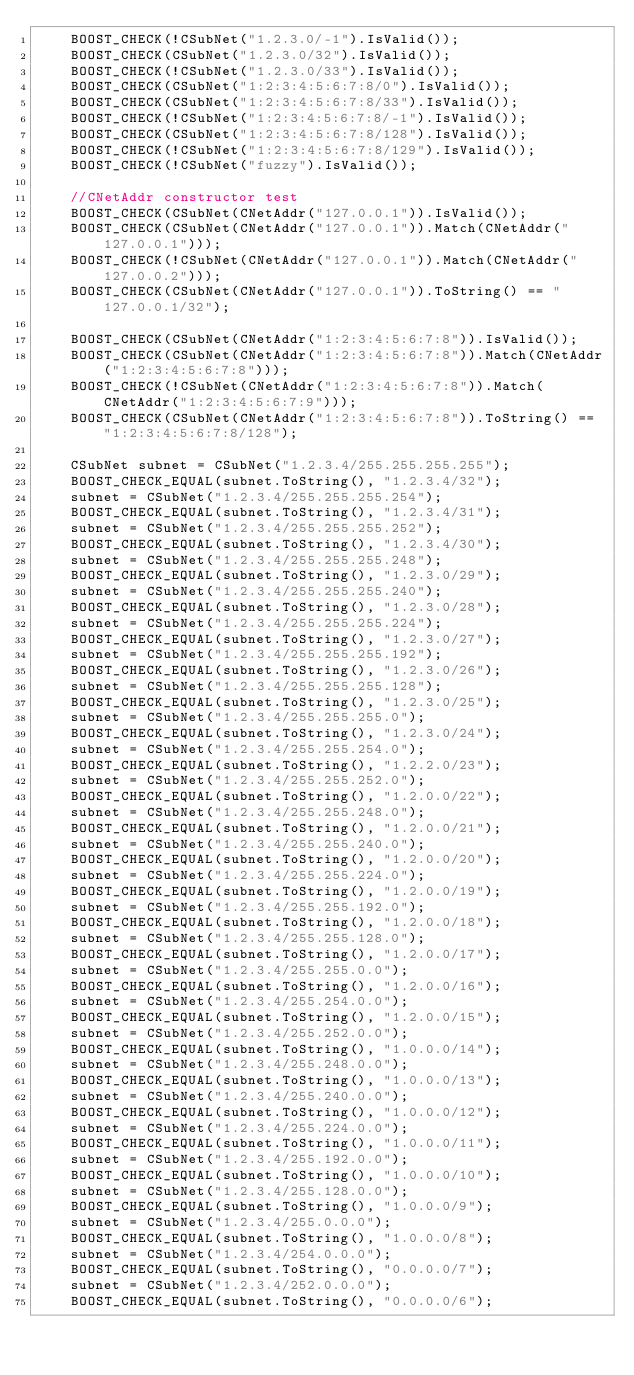Convert code to text. <code><loc_0><loc_0><loc_500><loc_500><_C++_>    BOOST_CHECK(!CSubNet("1.2.3.0/-1").IsValid());
    BOOST_CHECK(CSubNet("1.2.3.0/32").IsValid());
    BOOST_CHECK(!CSubNet("1.2.3.0/33").IsValid());
    BOOST_CHECK(CSubNet("1:2:3:4:5:6:7:8/0").IsValid());
    BOOST_CHECK(CSubNet("1:2:3:4:5:6:7:8/33").IsValid());
    BOOST_CHECK(!CSubNet("1:2:3:4:5:6:7:8/-1").IsValid());
    BOOST_CHECK(CSubNet("1:2:3:4:5:6:7:8/128").IsValid());
    BOOST_CHECK(!CSubNet("1:2:3:4:5:6:7:8/129").IsValid());
    BOOST_CHECK(!CSubNet("fuzzy").IsValid());

    //CNetAddr constructor test
    BOOST_CHECK(CSubNet(CNetAddr("127.0.0.1")).IsValid());
    BOOST_CHECK(CSubNet(CNetAddr("127.0.0.1")).Match(CNetAddr("127.0.0.1")));
    BOOST_CHECK(!CSubNet(CNetAddr("127.0.0.1")).Match(CNetAddr("127.0.0.2")));
    BOOST_CHECK(CSubNet(CNetAddr("127.0.0.1")).ToString() == "127.0.0.1/32");

    BOOST_CHECK(CSubNet(CNetAddr("1:2:3:4:5:6:7:8")).IsValid());
    BOOST_CHECK(CSubNet(CNetAddr("1:2:3:4:5:6:7:8")).Match(CNetAddr("1:2:3:4:5:6:7:8")));
    BOOST_CHECK(!CSubNet(CNetAddr("1:2:3:4:5:6:7:8")).Match(CNetAddr("1:2:3:4:5:6:7:9")));
    BOOST_CHECK(CSubNet(CNetAddr("1:2:3:4:5:6:7:8")).ToString() == "1:2:3:4:5:6:7:8/128");

    CSubNet subnet = CSubNet("1.2.3.4/255.255.255.255");
    BOOST_CHECK_EQUAL(subnet.ToString(), "1.2.3.4/32");
    subnet = CSubNet("1.2.3.4/255.255.255.254");
    BOOST_CHECK_EQUAL(subnet.ToString(), "1.2.3.4/31");
    subnet = CSubNet("1.2.3.4/255.255.255.252");
    BOOST_CHECK_EQUAL(subnet.ToString(), "1.2.3.4/30");
    subnet = CSubNet("1.2.3.4/255.255.255.248");
    BOOST_CHECK_EQUAL(subnet.ToString(), "1.2.3.0/29");
    subnet = CSubNet("1.2.3.4/255.255.255.240");
    BOOST_CHECK_EQUAL(subnet.ToString(), "1.2.3.0/28");
    subnet = CSubNet("1.2.3.4/255.255.255.224");
    BOOST_CHECK_EQUAL(subnet.ToString(), "1.2.3.0/27");
    subnet = CSubNet("1.2.3.4/255.255.255.192");
    BOOST_CHECK_EQUAL(subnet.ToString(), "1.2.3.0/26");
    subnet = CSubNet("1.2.3.4/255.255.255.128");
    BOOST_CHECK_EQUAL(subnet.ToString(), "1.2.3.0/25");
    subnet = CSubNet("1.2.3.4/255.255.255.0");
    BOOST_CHECK_EQUAL(subnet.ToString(), "1.2.3.0/24");
    subnet = CSubNet("1.2.3.4/255.255.254.0");
    BOOST_CHECK_EQUAL(subnet.ToString(), "1.2.2.0/23");
    subnet = CSubNet("1.2.3.4/255.255.252.0");
    BOOST_CHECK_EQUAL(subnet.ToString(), "1.2.0.0/22");
    subnet = CSubNet("1.2.3.4/255.255.248.0");
    BOOST_CHECK_EQUAL(subnet.ToString(), "1.2.0.0/21");
    subnet = CSubNet("1.2.3.4/255.255.240.0");
    BOOST_CHECK_EQUAL(subnet.ToString(), "1.2.0.0/20");
    subnet = CSubNet("1.2.3.4/255.255.224.0");
    BOOST_CHECK_EQUAL(subnet.ToString(), "1.2.0.0/19");
    subnet = CSubNet("1.2.3.4/255.255.192.0");
    BOOST_CHECK_EQUAL(subnet.ToString(), "1.2.0.0/18");
    subnet = CSubNet("1.2.3.4/255.255.128.0");
    BOOST_CHECK_EQUAL(subnet.ToString(), "1.2.0.0/17");
    subnet = CSubNet("1.2.3.4/255.255.0.0");
    BOOST_CHECK_EQUAL(subnet.ToString(), "1.2.0.0/16");
    subnet = CSubNet("1.2.3.4/255.254.0.0");
    BOOST_CHECK_EQUAL(subnet.ToString(), "1.2.0.0/15");
    subnet = CSubNet("1.2.3.4/255.252.0.0");
    BOOST_CHECK_EQUAL(subnet.ToString(), "1.0.0.0/14");
    subnet = CSubNet("1.2.3.4/255.248.0.0");
    BOOST_CHECK_EQUAL(subnet.ToString(), "1.0.0.0/13");
    subnet = CSubNet("1.2.3.4/255.240.0.0");
    BOOST_CHECK_EQUAL(subnet.ToString(), "1.0.0.0/12");
    subnet = CSubNet("1.2.3.4/255.224.0.0");
    BOOST_CHECK_EQUAL(subnet.ToString(), "1.0.0.0/11");
    subnet = CSubNet("1.2.3.4/255.192.0.0");
    BOOST_CHECK_EQUAL(subnet.ToString(), "1.0.0.0/10");
    subnet = CSubNet("1.2.3.4/255.128.0.0");
    BOOST_CHECK_EQUAL(subnet.ToString(), "1.0.0.0/9");
    subnet = CSubNet("1.2.3.4/255.0.0.0");
    BOOST_CHECK_EQUAL(subnet.ToString(), "1.0.0.0/8");
    subnet = CSubNet("1.2.3.4/254.0.0.0");
    BOOST_CHECK_EQUAL(subnet.ToString(), "0.0.0.0/7");
    subnet = CSubNet("1.2.3.4/252.0.0.0");
    BOOST_CHECK_EQUAL(subnet.ToString(), "0.0.0.0/6");</code> 